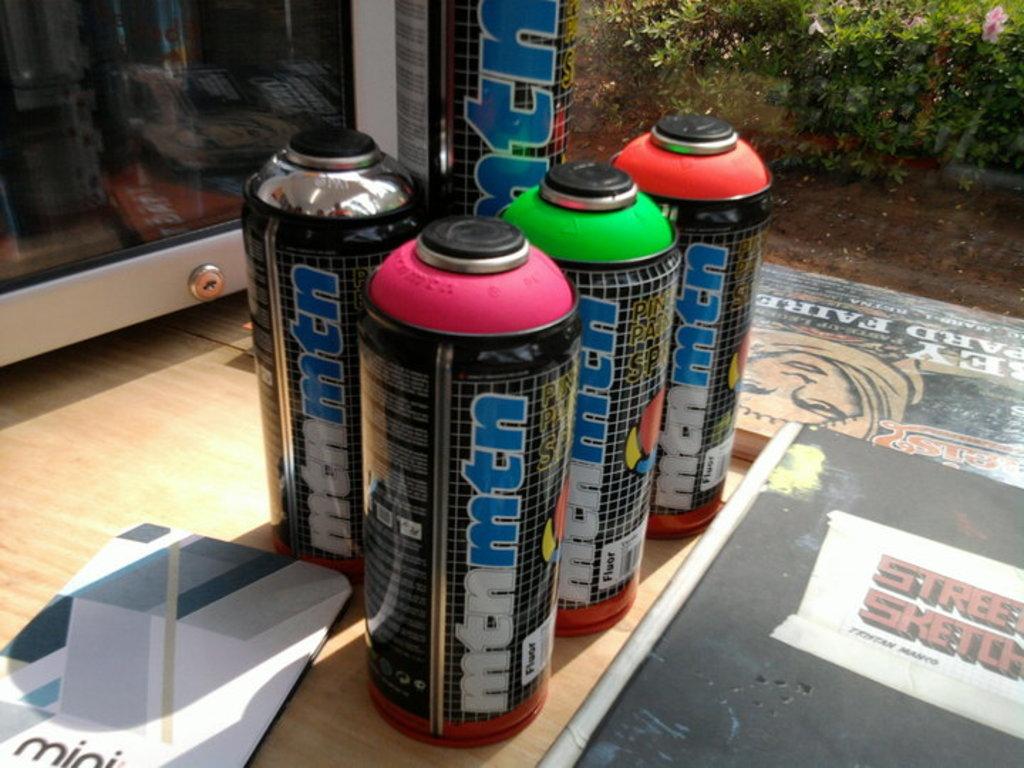What brand are the bottles?
Offer a terse response. Mtn. What's it say on the book?
Give a very brief answer. Street sketch. 